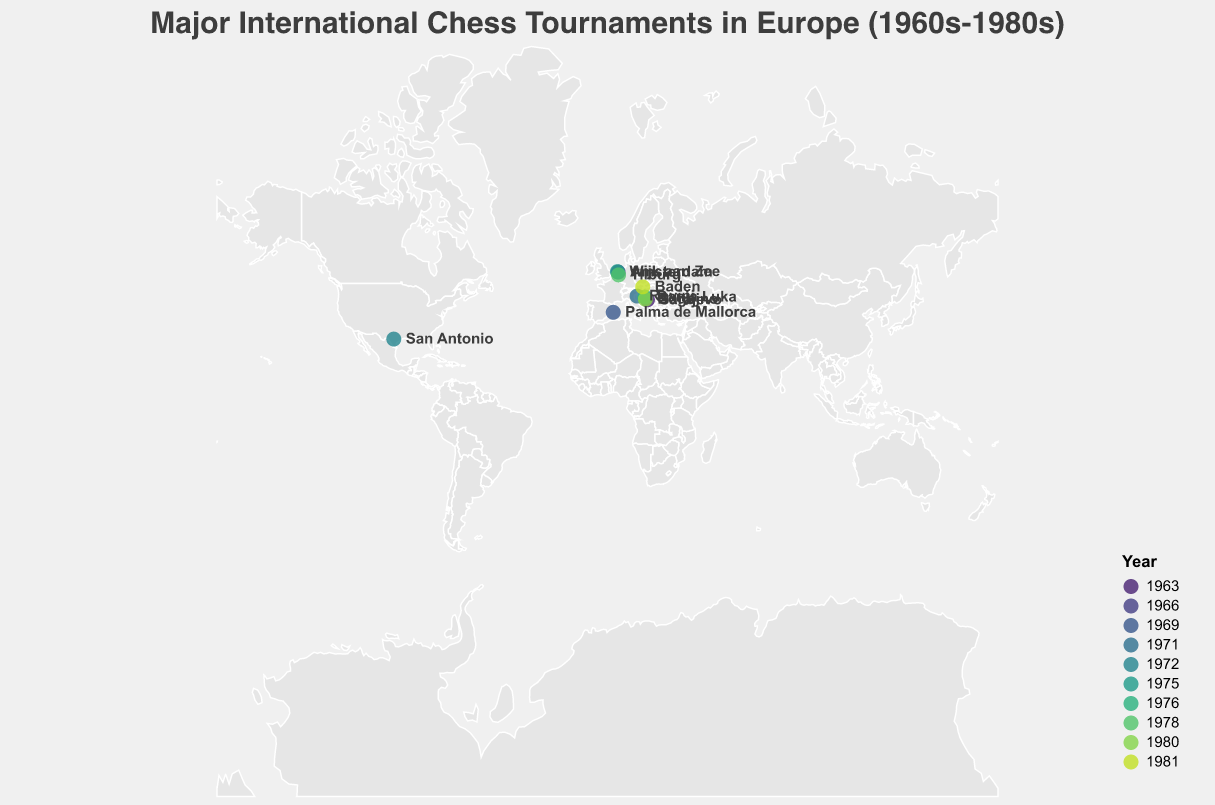Which city had the earliest chess tournament on the map? The figure's color gradient for years shows earlier years in lighter colors towards the bottom right of the legend. By examining the city and the provided data, Sarajevo in 1963 is the earliest.
Answer: Sarajevo How many tournaments were held in the Netherlands? The tooltip data reveals the tournaments' locations. By inspecting and counting the points in the Netherlands, we see Amsterdam (1966), Wijk aan Zee (1975), and Tilburg (1978).
Answer: 3 Which country hosted the most tournaments? Observing the distribution of points and referring to the tooltips and text labels, Bosnia and Herzegovina hosted three tournaments: Sarajevo (1963), Banja Luka (1976), and Bugojno (1980).
Answer: Bosnia and Herzegovina What is the northernmost tournament location on the map? By comparing latitudes of the points, Amsterdam (52.3676) and Wijk aan Zee (52.4934) are the top contenders. Wijk aan Zee has a slightly higher latitude.
Answer: Wijk aan Zee What is the average year of the tournaments held in Bosnia and Herzegovina? Sarajevo (1963), Banja Luka (1976), and Bugojno (1980). Calculate the average year: (1963 + 1976 + 1980) / 3 = 1973.
Answer: 1973 Which two tournaments were held closest in time? Examining the years across the points, San Antonio (1972) and Wijk aan Zee (1975) were held three years apart, which is the smallest gap.
Answer: San Antonio and Wijk aan Zee Which city hosted the latest tournament in the dataset? By referring to the color gradient and tooltips, the last year in the timeline is 1981, corresponding to Baden in Austria.
Answer: Baden Which city in Bosnia and Herzegovina hosted a tournament in 1976? By checking the points and tooltip data for Bosnia and Herzegovina for the year 1976, Banja Luka is the hosting city.
Answer: Banja Luka How many countries in Europe had chess tournaments according to the data? By counting the unique countries in the dataset while excluding any non-European countries (United States), we have 6 European countries: Bosnia and Herzegovina, Netherlands, Spain, Croatia, Austria, and Netherlands twice is counted once.
Answer: 6 Are there any tournaments that happened outside of Europe? The only tournament outside Europe is the San Antonio International Chess Tournament in the United States.
Answer: Yes 